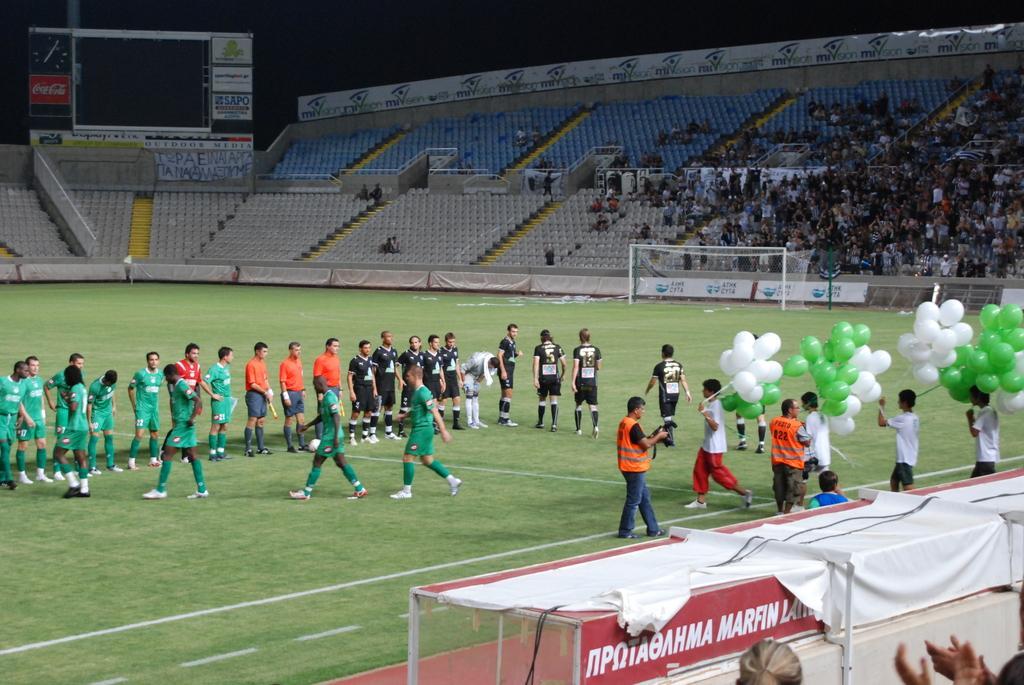Please provide a concise description of this image. Here we can see group of people on the ground and they are holding balloons. Here we can see cloth, boards, and a mesh. In the background we can see group of people sitting on the chairs and there is a screen. 